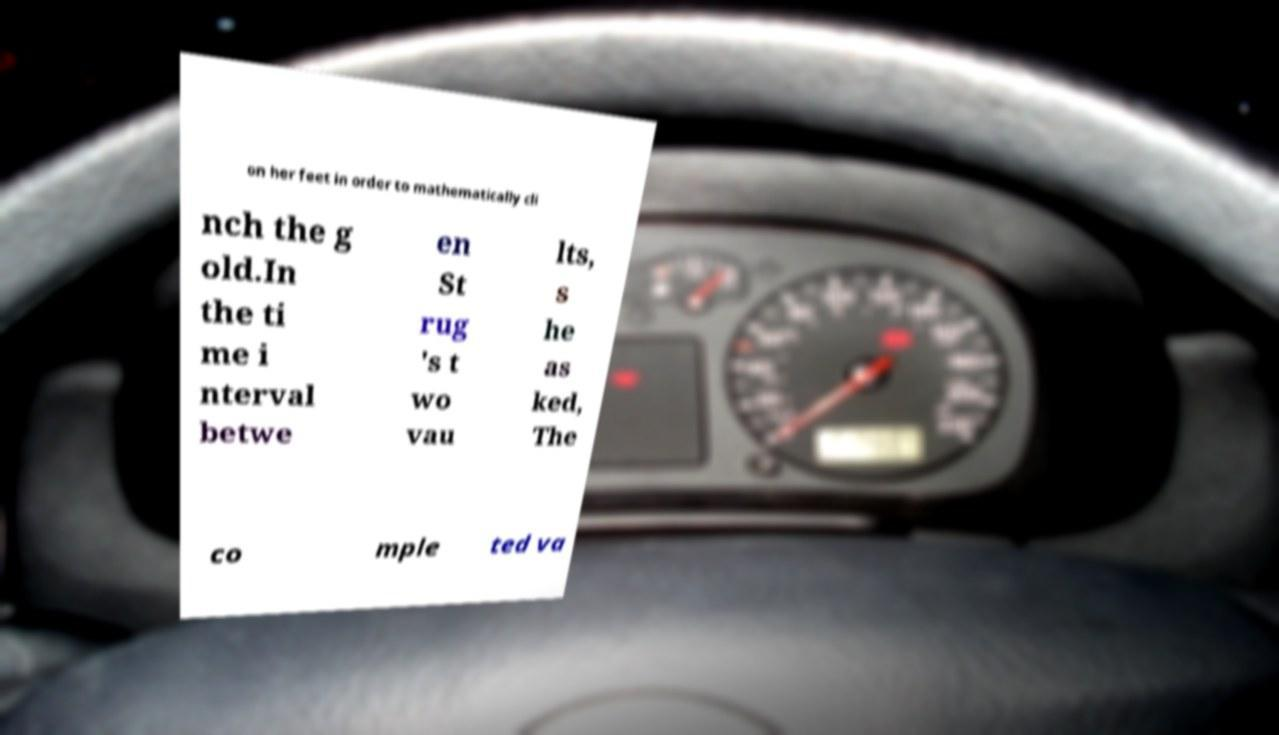Could you assist in decoding the text presented in this image and type it out clearly? on her feet in order to mathematically cli nch the g old.In the ti me i nterval betwe en St rug 's t wo vau lts, s he as ked, The co mple ted va 